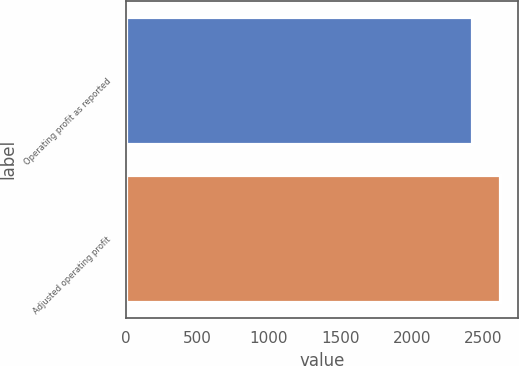<chart> <loc_0><loc_0><loc_500><loc_500><bar_chart><fcel>Operating profit as reported<fcel>Adjusted operating profit<nl><fcel>2419.9<fcel>2612.7<nl></chart> 